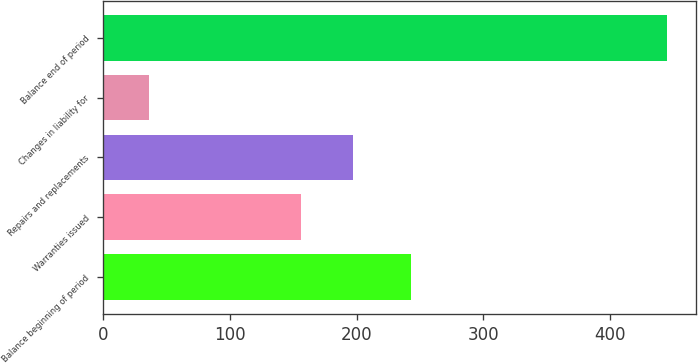Convert chart to OTSL. <chart><loc_0><loc_0><loc_500><loc_500><bar_chart><fcel>Balance beginning of period<fcel>Warranties issued<fcel>Repairs and replacements<fcel>Changes in liability for<fcel>Balance end of period<nl><fcel>243<fcel>156<fcel>196.9<fcel>36<fcel>445<nl></chart> 